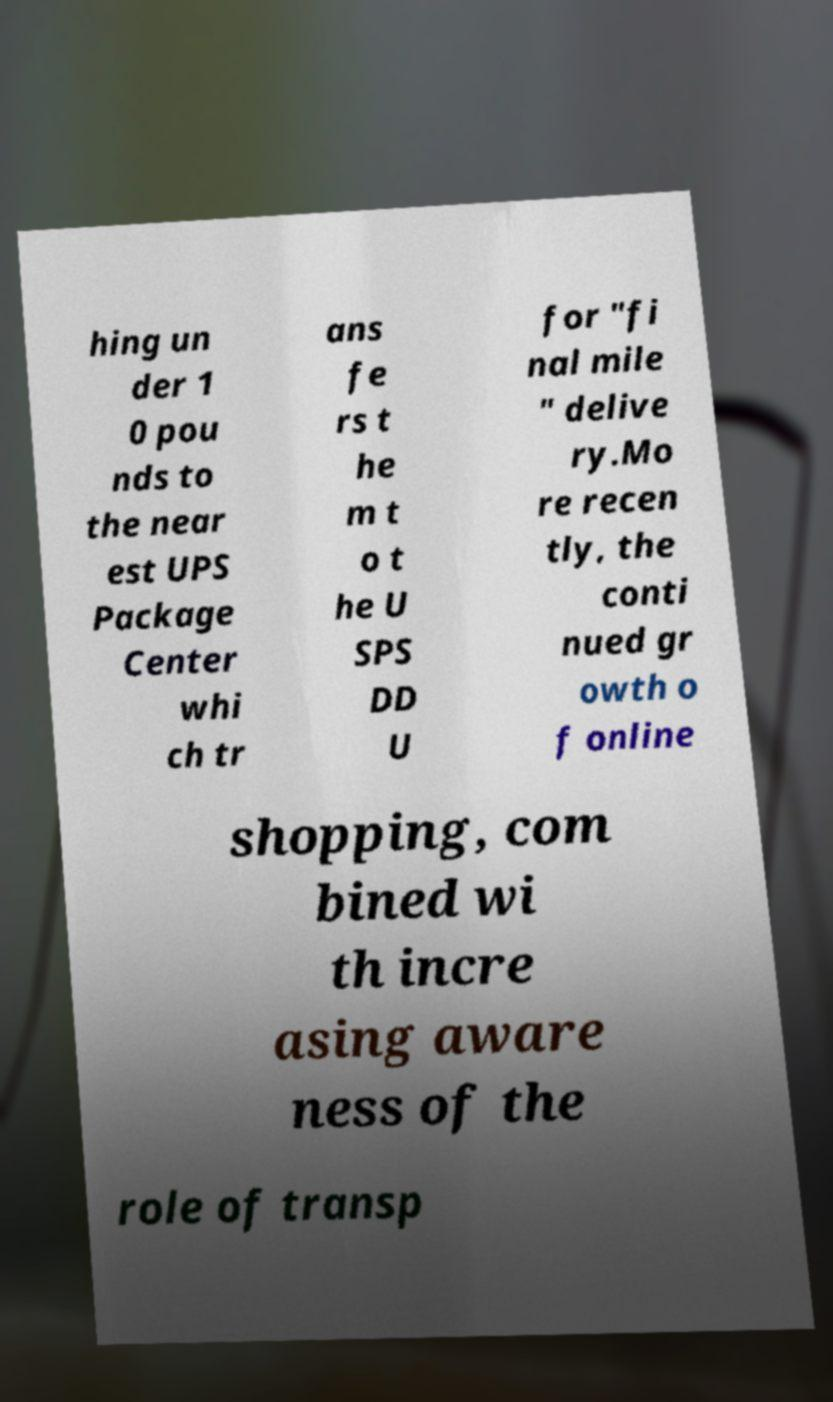Can you read and provide the text displayed in the image?This photo seems to have some interesting text. Can you extract and type it out for me? hing un der 1 0 pou nds to the near est UPS Package Center whi ch tr ans fe rs t he m t o t he U SPS DD U for "fi nal mile " delive ry.Mo re recen tly, the conti nued gr owth o f online shopping, com bined wi th incre asing aware ness of the role of transp 